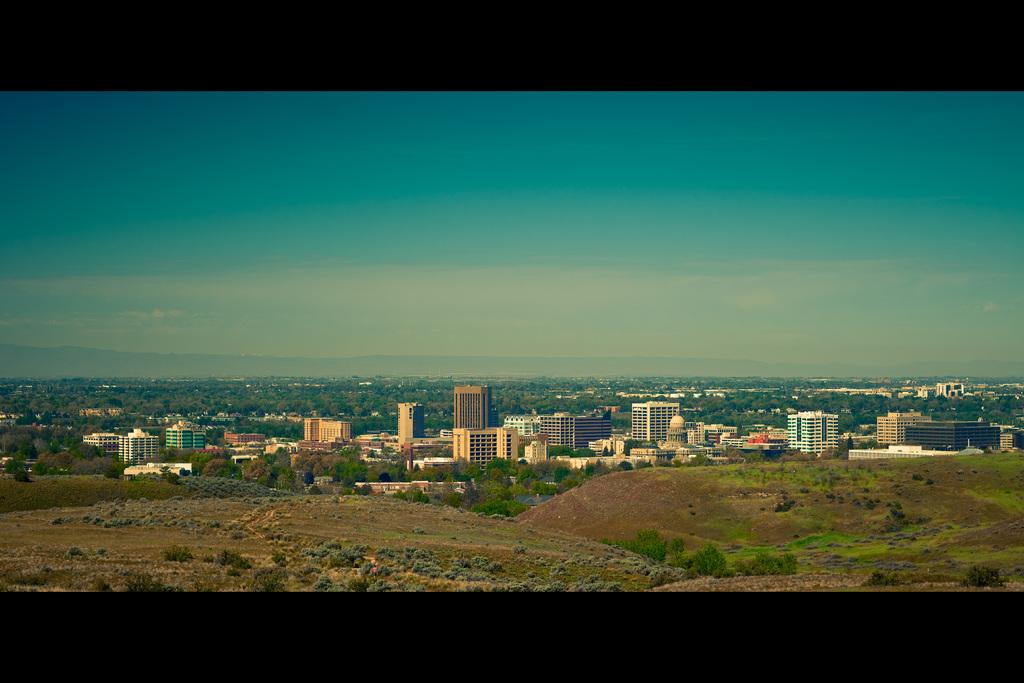What type of structures can be seen in the image? There are buildings in the image. What other natural elements are present in the image? There are plants and trees in the image. What can be seen in the background of the image? The sky is visible in the background of the image. Where is the throne located in the image? There is no throne present in the image. Is there a volcano visible in the image? There is no volcano present in the image. 